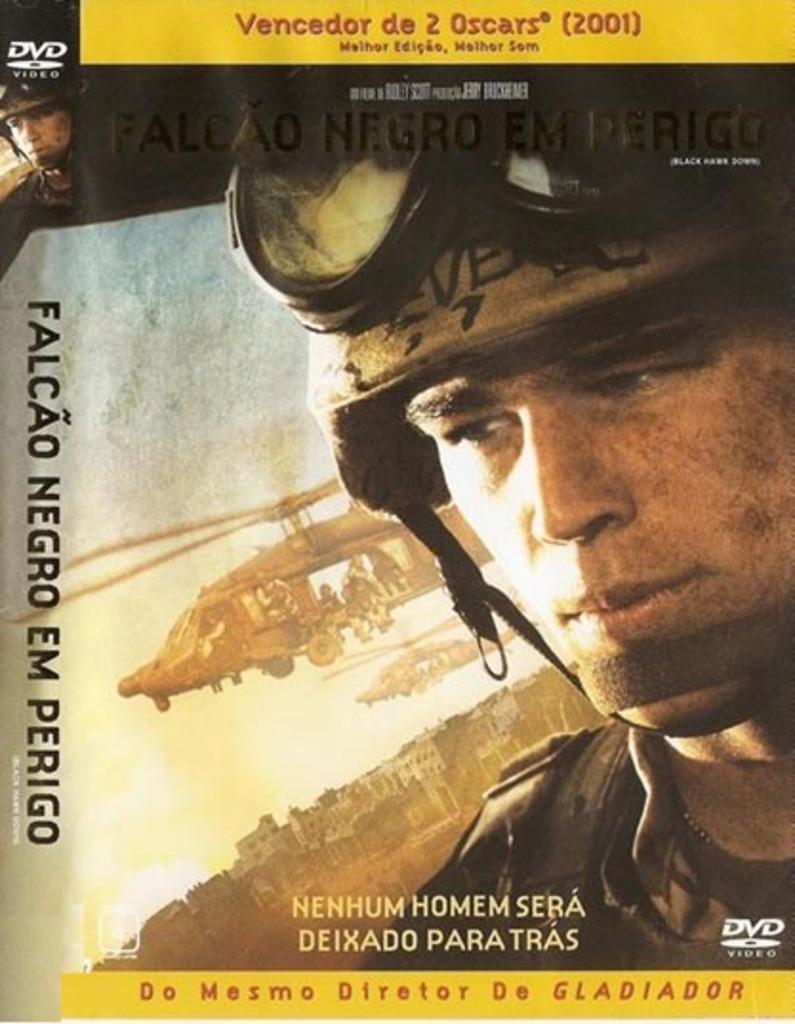What video format is this?
Provide a succinct answer. Dvd. What is the name of this movie?
Provide a short and direct response. Falcao negro em perigo. 